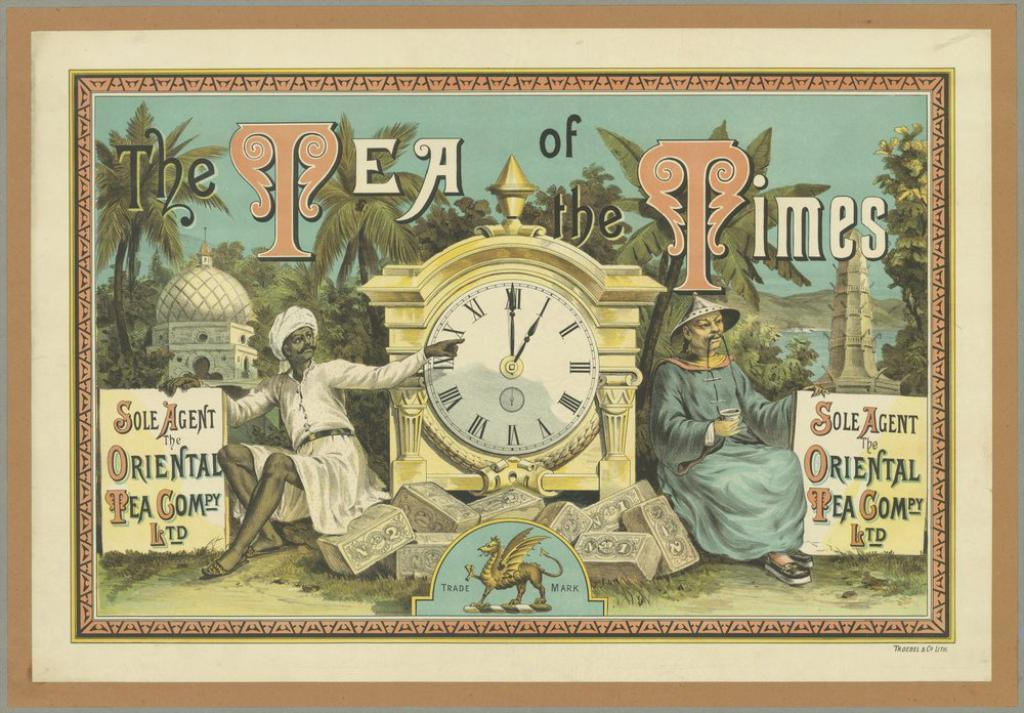<image>
Offer a succinct explanation of the picture presented. A painting that says Tea of Times has a drawing of a man by a clock. 